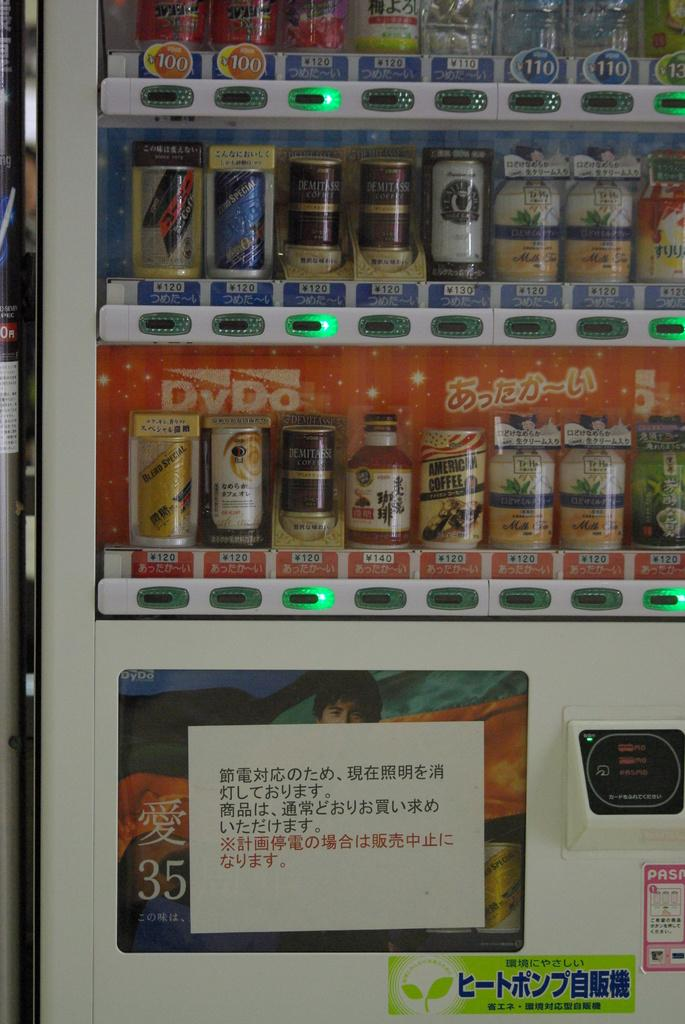<image>
Give a short and clear explanation of the subsequent image. A vending machine has several cans and bottles of drink to choose from including Demitasse coffee. 